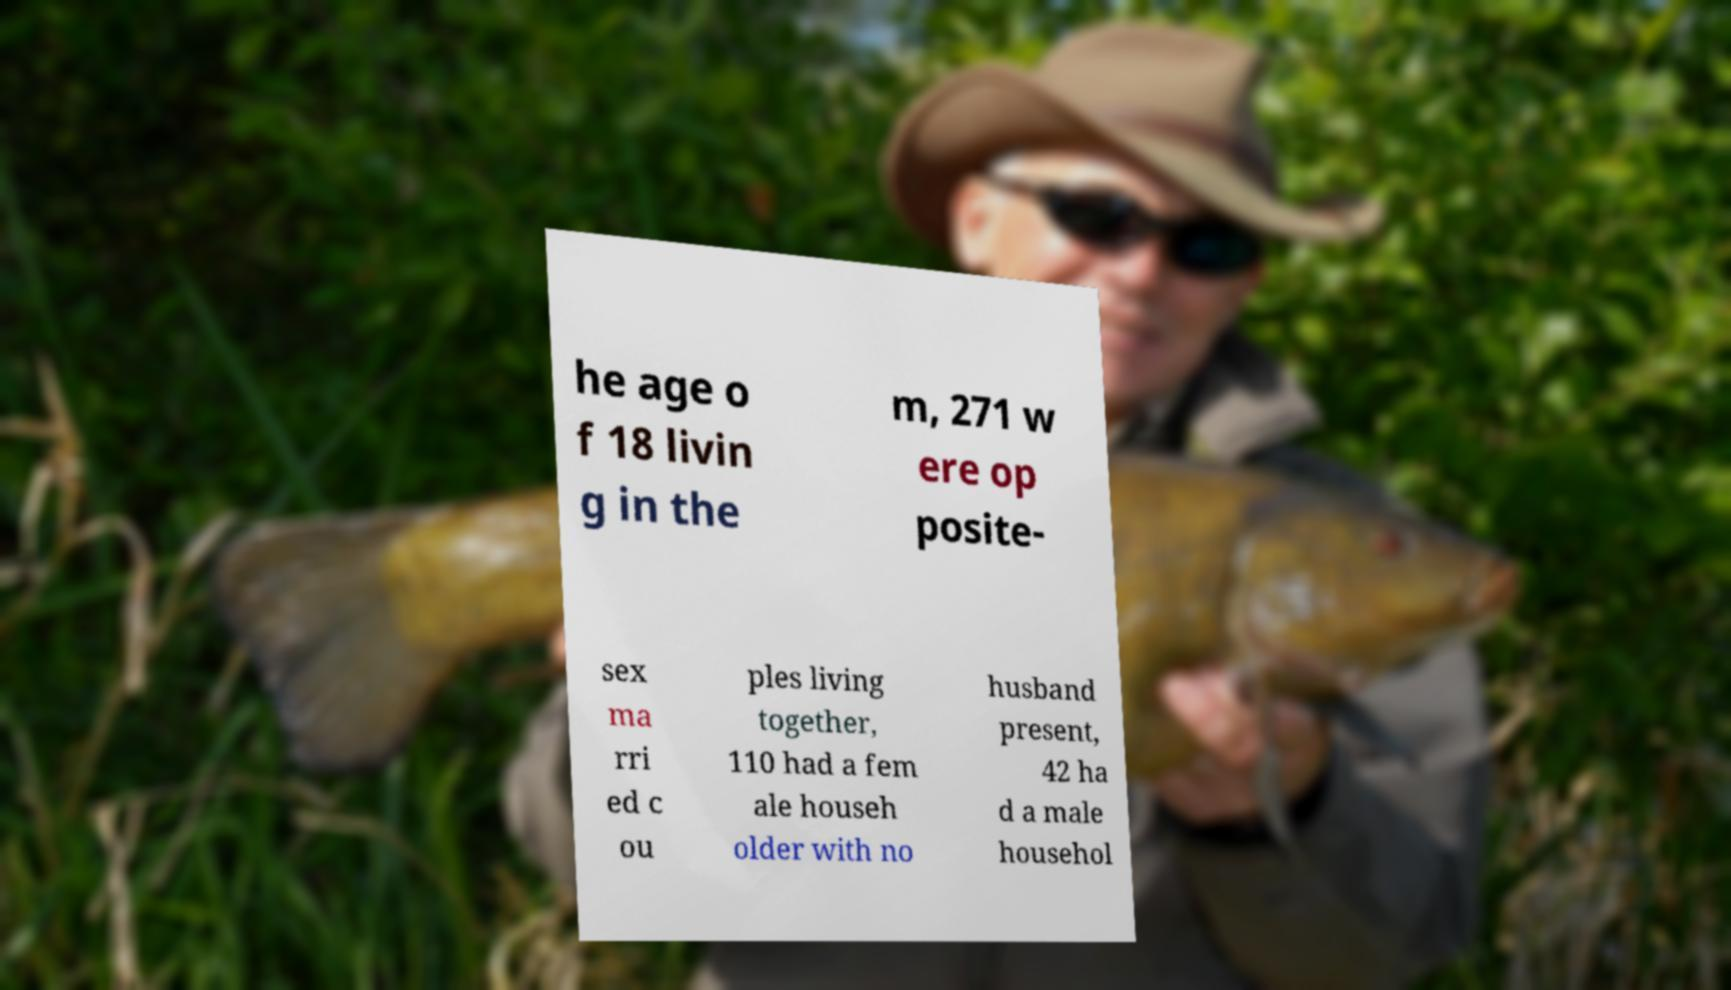Can you accurately transcribe the text from the provided image for me? he age o f 18 livin g in the m, 271 w ere op posite- sex ma rri ed c ou ples living together, 110 had a fem ale househ older with no husband present, 42 ha d a male househol 